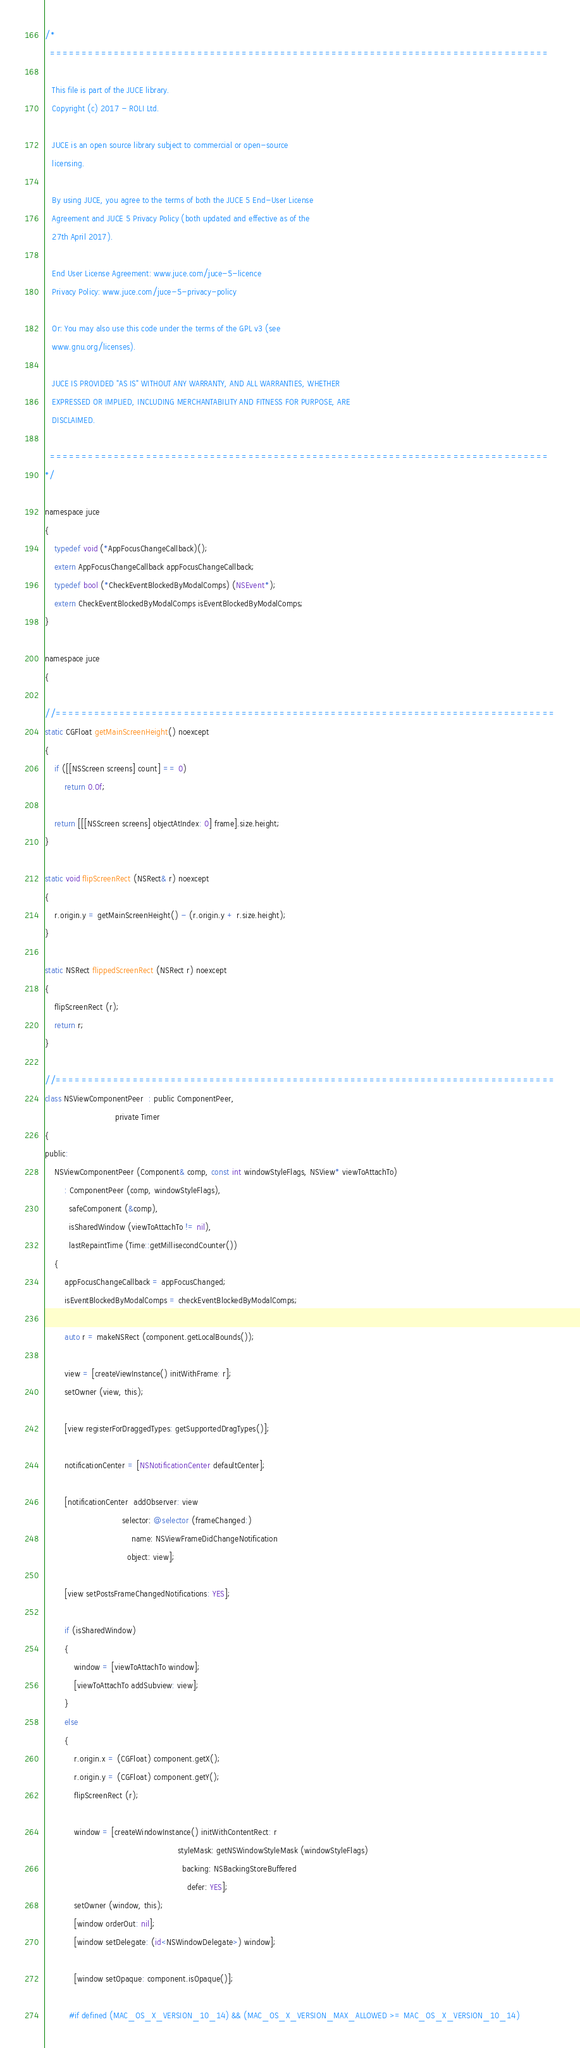Convert code to text. <code><loc_0><loc_0><loc_500><loc_500><_ObjectiveC_>/*
  ==============================================================================

   This file is part of the JUCE library.
   Copyright (c) 2017 - ROLI Ltd.

   JUCE is an open source library subject to commercial or open-source
   licensing.

   By using JUCE, you agree to the terms of both the JUCE 5 End-User License
   Agreement and JUCE 5 Privacy Policy (both updated and effective as of the
   27th April 2017).

   End User License Agreement: www.juce.com/juce-5-licence
   Privacy Policy: www.juce.com/juce-5-privacy-policy

   Or: You may also use this code under the terms of the GPL v3 (see
   www.gnu.org/licenses).

   JUCE IS PROVIDED "AS IS" WITHOUT ANY WARRANTY, AND ALL WARRANTIES, WHETHER
   EXPRESSED OR IMPLIED, INCLUDING MERCHANTABILITY AND FITNESS FOR PURPOSE, ARE
   DISCLAIMED.

  ==============================================================================
*/

namespace juce
{
    typedef void (*AppFocusChangeCallback)();
    extern AppFocusChangeCallback appFocusChangeCallback;
    typedef bool (*CheckEventBlockedByModalComps) (NSEvent*);
    extern CheckEventBlockedByModalComps isEventBlockedByModalComps;
}

namespace juce
{

//==============================================================================
static CGFloat getMainScreenHeight() noexcept
{
    if ([[NSScreen screens] count] == 0)
        return 0.0f;

    return [[[NSScreen screens] objectAtIndex: 0] frame].size.height;
}

static void flipScreenRect (NSRect& r) noexcept
{
    r.origin.y = getMainScreenHeight() - (r.origin.y + r.size.height);
}

static NSRect flippedScreenRect (NSRect r) noexcept
{
    flipScreenRect (r);
    return r;
}

//==============================================================================
class NSViewComponentPeer  : public ComponentPeer,
                             private Timer
{
public:
    NSViewComponentPeer (Component& comp, const int windowStyleFlags, NSView* viewToAttachTo)
        : ComponentPeer (comp, windowStyleFlags),
          safeComponent (&comp),
          isSharedWindow (viewToAttachTo != nil),
          lastRepaintTime (Time::getMillisecondCounter())
    {
        appFocusChangeCallback = appFocusChanged;
        isEventBlockedByModalComps = checkEventBlockedByModalComps;

        auto r = makeNSRect (component.getLocalBounds());

        view = [createViewInstance() initWithFrame: r];
        setOwner (view, this);

        [view registerForDraggedTypes: getSupportedDragTypes()];

        notificationCenter = [NSNotificationCenter defaultCenter];

        [notificationCenter  addObserver: view
                                selector: @selector (frameChanged:)
                                    name: NSViewFrameDidChangeNotification
                                  object: view];

        [view setPostsFrameChangedNotifications: YES];

        if (isSharedWindow)
        {
            window = [viewToAttachTo window];
            [viewToAttachTo addSubview: view];
        }
        else
        {
            r.origin.x = (CGFloat) component.getX();
            r.origin.y = (CGFloat) component.getY();
            flipScreenRect (r);

            window = [createWindowInstance() initWithContentRect: r
                                                       styleMask: getNSWindowStyleMask (windowStyleFlags)
                                                         backing: NSBackingStoreBuffered
                                                           defer: YES];
            setOwner (window, this);
            [window orderOut: nil];
            [window setDelegate: (id<NSWindowDelegate>) window];

            [window setOpaque: component.isOpaque()];

          #if defined (MAC_OS_X_VERSION_10_14) && (MAC_OS_X_VERSION_MAX_ALLOWED >= MAC_OS_X_VERSION_10_14)</code> 